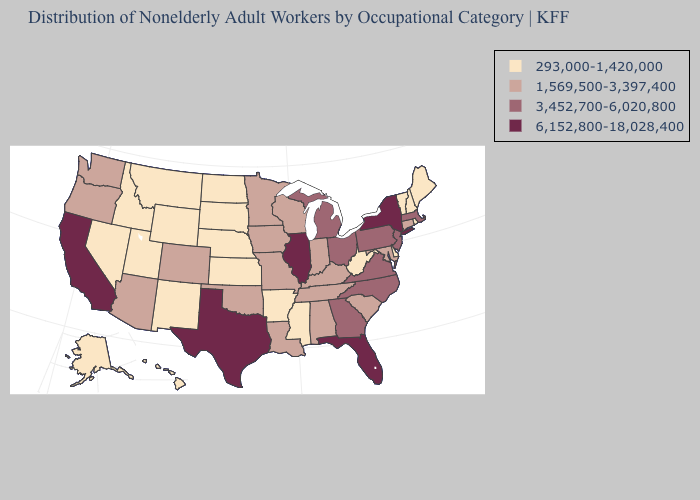Does the first symbol in the legend represent the smallest category?
Keep it brief. Yes. Name the states that have a value in the range 3,452,700-6,020,800?
Concise answer only. Georgia, Massachusetts, Michigan, New Jersey, North Carolina, Ohio, Pennsylvania, Virginia. What is the value of North Dakota?
Be succinct. 293,000-1,420,000. Does the first symbol in the legend represent the smallest category?
Write a very short answer. Yes. Name the states that have a value in the range 6,152,800-18,028,400?
Short answer required. California, Florida, Illinois, New York, Texas. Which states have the lowest value in the USA?
Short answer required. Alaska, Arkansas, Delaware, Hawaii, Idaho, Kansas, Maine, Mississippi, Montana, Nebraska, Nevada, New Hampshire, New Mexico, North Dakota, Rhode Island, South Dakota, Utah, Vermont, West Virginia, Wyoming. Name the states that have a value in the range 6,152,800-18,028,400?
Be succinct. California, Florida, Illinois, New York, Texas. What is the value of Alaska?
Concise answer only. 293,000-1,420,000. Name the states that have a value in the range 293,000-1,420,000?
Give a very brief answer. Alaska, Arkansas, Delaware, Hawaii, Idaho, Kansas, Maine, Mississippi, Montana, Nebraska, Nevada, New Hampshire, New Mexico, North Dakota, Rhode Island, South Dakota, Utah, Vermont, West Virginia, Wyoming. Among the states that border Colorado , does Arizona have the lowest value?
Be succinct. No. Among the states that border South Carolina , which have the highest value?
Write a very short answer. Georgia, North Carolina. Among the states that border North Carolina , does Georgia have the lowest value?
Write a very short answer. No. Does New York have the same value as Florida?
Concise answer only. Yes. What is the value of West Virginia?
Concise answer only. 293,000-1,420,000. What is the value of Georgia?
Quick response, please. 3,452,700-6,020,800. 